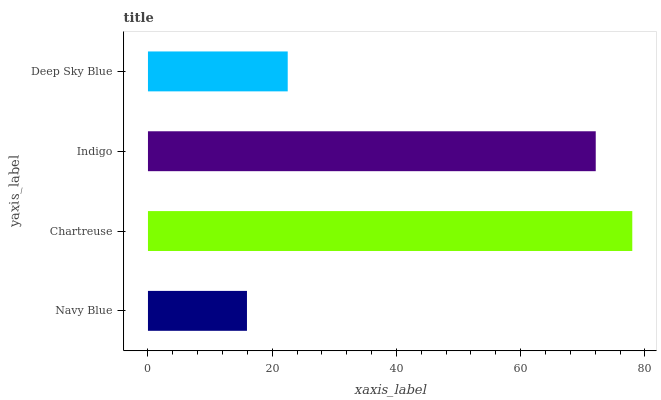Is Navy Blue the minimum?
Answer yes or no. Yes. Is Chartreuse the maximum?
Answer yes or no. Yes. Is Indigo the minimum?
Answer yes or no. No. Is Indigo the maximum?
Answer yes or no. No. Is Chartreuse greater than Indigo?
Answer yes or no. Yes. Is Indigo less than Chartreuse?
Answer yes or no. Yes. Is Indigo greater than Chartreuse?
Answer yes or no. No. Is Chartreuse less than Indigo?
Answer yes or no. No. Is Indigo the high median?
Answer yes or no. Yes. Is Deep Sky Blue the low median?
Answer yes or no. Yes. Is Chartreuse the high median?
Answer yes or no. No. Is Chartreuse the low median?
Answer yes or no. No. 